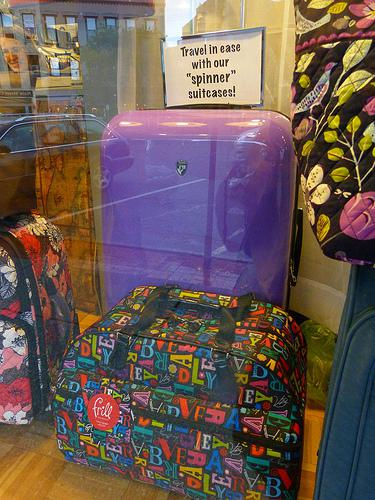Question: what is on the bottom suitcase?
Choices:
A. Notes.
B. Color.
C. Letters.
D. Ink blotches.
Answer with the letter. Answer: C Question: what can you see in the window?
Choices:
A. A person.
B. An animal.
C. A reflection.
D. Food.
Answer with the letter. Answer: C Question: who can you see in the window?
Choices:
A. The man.
B. The girl.
C. The men.
D. The woman.
Answer with the letter. Answer: D Question: where are the suitcases?
Choices:
A. In front of the glass.
B. On the table.
C. Behind the glass.
D. On the floor.
Answer with the letter. Answer: C Question: why are the suitcases in the window?
Choices:
A. They are placed there.
B. They are lost there.
C. They are on display.
D. They are window cases.
Answer with the letter. Answer: C 